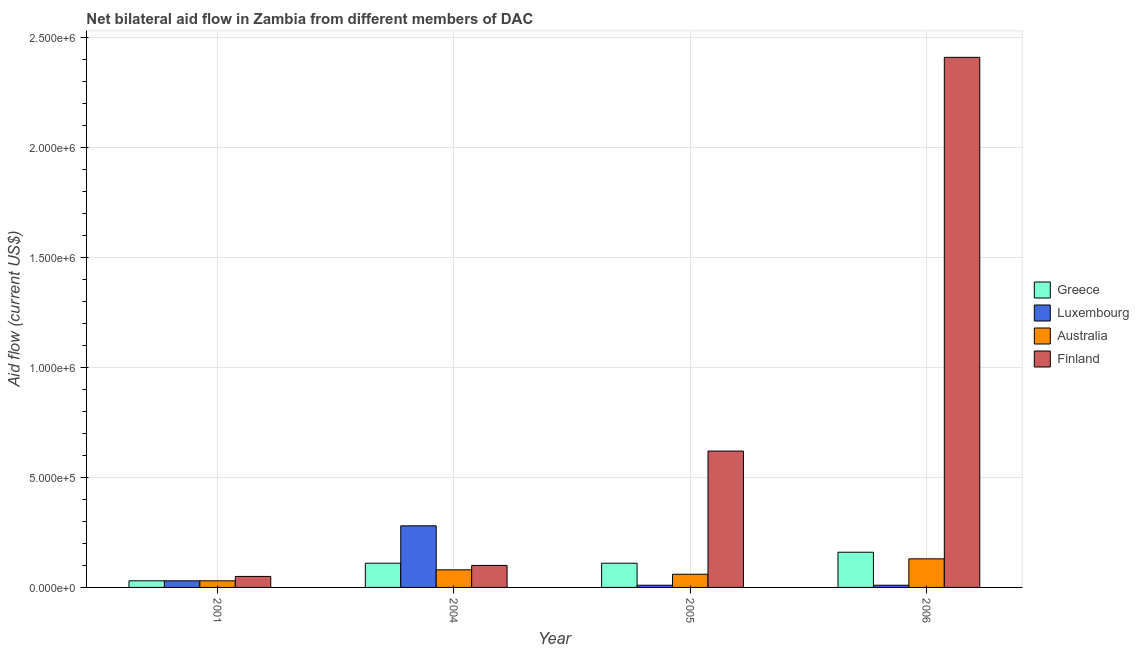How many groups of bars are there?
Your response must be concise. 4. Are the number of bars per tick equal to the number of legend labels?
Keep it short and to the point. Yes. How many bars are there on the 4th tick from the left?
Offer a terse response. 4. How many bars are there on the 4th tick from the right?
Keep it short and to the point. 4. In how many cases, is the number of bars for a given year not equal to the number of legend labels?
Give a very brief answer. 0. What is the amount of aid given by greece in 2001?
Your answer should be very brief. 3.00e+04. Across all years, what is the maximum amount of aid given by greece?
Keep it short and to the point. 1.60e+05. Across all years, what is the minimum amount of aid given by australia?
Offer a very short reply. 3.00e+04. In which year was the amount of aid given by australia maximum?
Ensure brevity in your answer.  2006. What is the total amount of aid given by greece in the graph?
Ensure brevity in your answer.  4.10e+05. What is the difference between the amount of aid given by australia in 2001 and that in 2005?
Keep it short and to the point. -3.00e+04. What is the difference between the amount of aid given by finland in 2005 and the amount of aid given by luxembourg in 2006?
Ensure brevity in your answer.  -1.79e+06. What is the average amount of aid given by greece per year?
Your answer should be compact. 1.02e+05. In the year 2004, what is the difference between the amount of aid given by luxembourg and amount of aid given by australia?
Keep it short and to the point. 0. What is the ratio of the amount of aid given by finland in 2004 to that in 2005?
Offer a very short reply. 0.16. Is the amount of aid given by luxembourg in 2004 less than that in 2006?
Your response must be concise. No. What is the difference between the highest and the lowest amount of aid given by luxembourg?
Your response must be concise. 2.70e+05. What does the 4th bar from the left in 2005 represents?
Keep it short and to the point. Finland. What does the 3rd bar from the right in 2004 represents?
Your answer should be compact. Luxembourg. What is the difference between two consecutive major ticks on the Y-axis?
Ensure brevity in your answer.  5.00e+05. Are the values on the major ticks of Y-axis written in scientific E-notation?
Provide a short and direct response. Yes. Does the graph contain any zero values?
Your answer should be very brief. No. Where does the legend appear in the graph?
Keep it short and to the point. Center right. How many legend labels are there?
Your answer should be very brief. 4. How are the legend labels stacked?
Ensure brevity in your answer.  Vertical. What is the title of the graph?
Offer a very short reply. Net bilateral aid flow in Zambia from different members of DAC. What is the label or title of the Y-axis?
Offer a very short reply. Aid flow (current US$). What is the Aid flow (current US$) of Luxembourg in 2001?
Your answer should be very brief. 3.00e+04. What is the Aid flow (current US$) of Finland in 2001?
Your response must be concise. 5.00e+04. What is the Aid flow (current US$) of Australia in 2004?
Your response must be concise. 8.00e+04. What is the Aid flow (current US$) of Greece in 2005?
Ensure brevity in your answer.  1.10e+05. What is the Aid flow (current US$) in Luxembourg in 2005?
Offer a very short reply. 10000. What is the Aid flow (current US$) in Australia in 2005?
Ensure brevity in your answer.  6.00e+04. What is the Aid flow (current US$) in Finland in 2005?
Provide a short and direct response. 6.20e+05. What is the Aid flow (current US$) of Greece in 2006?
Make the answer very short. 1.60e+05. What is the Aid flow (current US$) in Australia in 2006?
Provide a succinct answer. 1.30e+05. What is the Aid flow (current US$) of Finland in 2006?
Offer a very short reply. 2.41e+06. Across all years, what is the maximum Aid flow (current US$) in Finland?
Ensure brevity in your answer.  2.41e+06. Across all years, what is the minimum Aid flow (current US$) of Australia?
Offer a very short reply. 3.00e+04. What is the total Aid flow (current US$) in Luxembourg in the graph?
Offer a very short reply. 3.30e+05. What is the total Aid flow (current US$) in Australia in the graph?
Ensure brevity in your answer.  3.00e+05. What is the total Aid flow (current US$) in Finland in the graph?
Give a very brief answer. 3.18e+06. What is the difference between the Aid flow (current US$) of Luxembourg in 2001 and that in 2004?
Give a very brief answer. -2.50e+05. What is the difference between the Aid flow (current US$) in Greece in 2001 and that in 2005?
Your answer should be very brief. -8.00e+04. What is the difference between the Aid flow (current US$) of Luxembourg in 2001 and that in 2005?
Your response must be concise. 2.00e+04. What is the difference between the Aid flow (current US$) in Finland in 2001 and that in 2005?
Keep it short and to the point. -5.70e+05. What is the difference between the Aid flow (current US$) in Greece in 2001 and that in 2006?
Your answer should be compact. -1.30e+05. What is the difference between the Aid flow (current US$) in Australia in 2001 and that in 2006?
Your answer should be very brief. -1.00e+05. What is the difference between the Aid flow (current US$) in Finland in 2001 and that in 2006?
Provide a succinct answer. -2.36e+06. What is the difference between the Aid flow (current US$) of Greece in 2004 and that in 2005?
Your answer should be compact. 0. What is the difference between the Aid flow (current US$) in Finland in 2004 and that in 2005?
Your answer should be compact. -5.20e+05. What is the difference between the Aid flow (current US$) of Luxembourg in 2004 and that in 2006?
Keep it short and to the point. 2.70e+05. What is the difference between the Aid flow (current US$) in Australia in 2004 and that in 2006?
Ensure brevity in your answer.  -5.00e+04. What is the difference between the Aid flow (current US$) of Finland in 2004 and that in 2006?
Your answer should be very brief. -2.31e+06. What is the difference between the Aid flow (current US$) of Greece in 2005 and that in 2006?
Your response must be concise. -5.00e+04. What is the difference between the Aid flow (current US$) in Finland in 2005 and that in 2006?
Your answer should be very brief. -1.79e+06. What is the difference between the Aid flow (current US$) in Greece in 2001 and the Aid flow (current US$) in Australia in 2004?
Offer a terse response. -5.00e+04. What is the difference between the Aid flow (current US$) of Greece in 2001 and the Aid flow (current US$) of Finland in 2004?
Ensure brevity in your answer.  -7.00e+04. What is the difference between the Aid flow (current US$) of Greece in 2001 and the Aid flow (current US$) of Luxembourg in 2005?
Give a very brief answer. 2.00e+04. What is the difference between the Aid flow (current US$) of Greece in 2001 and the Aid flow (current US$) of Australia in 2005?
Offer a very short reply. -3.00e+04. What is the difference between the Aid flow (current US$) of Greece in 2001 and the Aid flow (current US$) of Finland in 2005?
Ensure brevity in your answer.  -5.90e+05. What is the difference between the Aid flow (current US$) in Luxembourg in 2001 and the Aid flow (current US$) in Australia in 2005?
Give a very brief answer. -3.00e+04. What is the difference between the Aid flow (current US$) in Luxembourg in 2001 and the Aid flow (current US$) in Finland in 2005?
Offer a very short reply. -5.90e+05. What is the difference between the Aid flow (current US$) of Australia in 2001 and the Aid flow (current US$) of Finland in 2005?
Your response must be concise. -5.90e+05. What is the difference between the Aid flow (current US$) in Greece in 2001 and the Aid flow (current US$) in Luxembourg in 2006?
Provide a short and direct response. 2.00e+04. What is the difference between the Aid flow (current US$) in Greece in 2001 and the Aid flow (current US$) in Finland in 2006?
Provide a succinct answer. -2.38e+06. What is the difference between the Aid flow (current US$) in Luxembourg in 2001 and the Aid flow (current US$) in Finland in 2006?
Your response must be concise. -2.38e+06. What is the difference between the Aid flow (current US$) of Australia in 2001 and the Aid flow (current US$) of Finland in 2006?
Your answer should be very brief. -2.38e+06. What is the difference between the Aid flow (current US$) of Greece in 2004 and the Aid flow (current US$) of Luxembourg in 2005?
Provide a succinct answer. 1.00e+05. What is the difference between the Aid flow (current US$) in Greece in 2004 and the Aid flow (current US$) in Finland in 2005?
Your response must be concise. -5.10e+05. What is the difference between the Aid flow (current US$) in Luxembourg in 2004 and the Aid flow (current US$) in Australia in 2005?
Provide a short and direct response. 2.20e+05. What is the difference between the Aid flow (current US$) of Australia in 2004 and the Aid flow (current US$) of Finland in 2005?
Your response must be concise. -5.40e+05. What is the difference between the Aid flow (current US$) in Greece in 2004 and the Aid flow (current US$) in Finland in 2006?
Provide a succinct answer. -2.30e+06. What is the difference between the Aid flow (current US$) in Luxembourg in 2004 and the Aid flow (current US$) in Finland in 2006?
Give a very brief answer. -2.13e+06. What is the difference between the Aid flow (current US$) in Australia in 2004 and the Aid flow (current US$) in Finland in 2006?
Offer a terse response. -2.33e+06. What is the difference between the Aid flow (current US$) of Greece in 2005 and the Aid flow (current US$) of Luxembourg in 2006?
Ensure brevity in your answer.  1.00e+05. What is the difference between the Aid flow (current US$) in Greece in 2005 and the Aid flow (current US$) in Finland in 2006?
Make the answer very short. -2.30e+06. What is the difference between the Aid flow (current US$) of Luxembourg in 2005 and the Aid flow (current US$) of Australia in 2006?
Offer a very short reply. -1.20e+05. What is the difference between the Aid flow (current US$) of Luxembourg in 2005 and the Aid flow (current US$) of Finland in 2006?
Your response must be concise. -2.40e+06. What is the difference between the Aid flow (current US$) in Australia in 2005 and the Aid flow (current US$) in Finland in 2006?
Provide a short and direct response. -2.35e+06. What is the average Aid flow (current US$) in Greece per year?
Keep it short and to the point. 1.02e+05. What is the average Aid flow (current US$) in Luxembourg per year?
Provide a short and direct response. 8.25e+04. What is the average Aid flow (current US$) in Australia per year?
Your answer should be very brief. 7.50e+04. What is the average Aid flow (current US$) in Finland per year?
Give a very brief answer. 7.95e+05. In the year 2001, what is the difference between the Aid flow (current US$) in Greece and Aid flow (current US$) in Finland?
Provide a succinct answer. -2.00e+04. In the year 2001, what is the difference between the Aid flow (current US$) of Luxembourg and Aid flow (current US$) of Australia?
Your response must be concise. 0. In the year 2001, what is the difference between the Aid flow (current US$) of Luxembourg and Aid flow (current US$) of Finland?
Your response must be concise. -2.00e+04. In the year 2004, what is the difference between the Aid flow (current US$) in Greece and Aid flow (current US$) in Australia?
Give a very brief answer. 3.00e+04. In the year 2004, what is the difference between the Aid flow (current US$) of Luxembourg and Aid flow (current US$) of Australia?
Your answer should be compact. 2.00e+05. In the year 2005, what is the difference between the Aid flow (current US$) in Greece and Aid flow (current US$) in Australia?
Give a very brief answer. 5.00e+04. In the year 2005, what is the difference between the Aid flow (current US$) of Greece and Aid flow (current US$) of Finland?
Keep it short and to the point. -5.10e+05. In the year 2005, what is the difference between the Aid flow (current US$) of Luxembourg and Aid flow (current US$) of Finland?
Offer a terse response. -6.10e+05. In the year 2005, what is the difference between the Aid flow (current US$) in Australia and Aid flow (current US$) in Finland?
Your answer should be very brief. -5.60e+05. In the year 2006, what is the difference between the Aid flow (current US$) in Greece and Aid flow (current US$) in Australia?
Your answer should be compact. 3.00e+04. In the year 2006, what is the difference between the Aid flow (current US$) of Greece and Aid flow (current US$) of Finland?
Offer a terse response. -2.25e+06. In the year 2006, what is the difference between the Aid flow (current US$) of Luxembourg and Aid flow (current US$) of Finland?
Ensure brevity in your answer.  -2.40e+06. In the year 2006, what is the difference between the Aid flow (current US$) of Australia and Aid flow (current US$) of Finland?
Your response must be concise. -2.28e+06. What is the ratio of the Aid flow (current US$) of Greece in 2001 to that in 2004?
Provide a short and direct response. 0.27. What is the ratio of the Aid flow (current US$) of Luxembourg in 2001 to that in 2004?
Ensure brevity in your answer.  0.11. What is the ratio of the Aid flow (current US$) of Greece in 2001 to that in 2005?
Make the answer very short. 0.27. What is the ratio of the Aid flow (current US$) in Finland in 2001 to that in 2005?
Your answer should be very brief. 0.08. What is the ratio of the Aid flow (current US$) in Greece in 2001 to that in 2006?
Make the answer very short. 0.19. What is the ratio of the Aid flow (current US$) of Luxembourg in 2001 to that in 2006?
Your answer should be compact. 3. What is the ratio of the Aid flow (current US$) in Australia in 2001 to that in 2006?
Your answer should be compact. 0.23. What is the ratio of the Aid flow (current US$) in Finland in 2001 to that in 2006?
Provide a succinct answer. 0.02. What is the ratio of the Aid flow (current US$) of Greece in 2004 to that in 2005?
Offer a very short reply. 1. What is the ratio of the Aid flow (current US$) in Luxembourg in 2004 to that in 2005?
Offer a terse response. 28. What is the ratio of the Aid flow (current US$) in Finland in 2004 to that in 2005?
Offer a terse response. 0.16. What is the ratio of the Aid flow (current US$) in Greece in 2004 to that in 2006?
Make the answer very short. 0.69. What is the ratio of the Aid flow (current US$) of Australia in 2004 to that in 2006?
Your response must be concise. 0.62. What is the ratio of the Aid flow (current US$) of Finland in 2004 to that in 2006?
Make the answer very short. 0.04. What is the ratio of the Aid flow (current US$) of Greece in 2005 to that in 2006?
Keep it short and to the point. 0.69. What is the ratio of the Aid flow (current US$) of Luxembourg in 2005 to that in 2006?
Offer a very short reply. 1. What is the ratio of the Aid flow (current US$) of Australia in 2005 to that in 2006?
Your response must be concise. 0.46. What is the ratio of the Aid flow (current US$) in Finland in 2005 to that in 2006?
Your response must be concise. 0.26. What is the difference between the highest and the second highest Aid flow (current US$) in Luxembourg?
Your response must be concise. 2.50e+05. What is the difference between the highest and the second highest Aid flow (current US$) in Australia?
Your response must be concise. 5.00e+04. What is the difference between the highest and the second highest Aid flow (current US$) of Finland?
Provide a short and direct response. 1.79e+06. What is the difference between the highest and the lowest Aid flow (current US$) of Luxembourg?
Your response must be concise. 2.70e+05. What is the difference between the highest and the lowest Aid flow (current US$) in Australia?
Ensure brevity in your answer.  1.00e+05. What is the difference between the highest and the lowest Aid flow (current US$) of Finland?
Ensure brevity in your answer.  2.36e+06. 